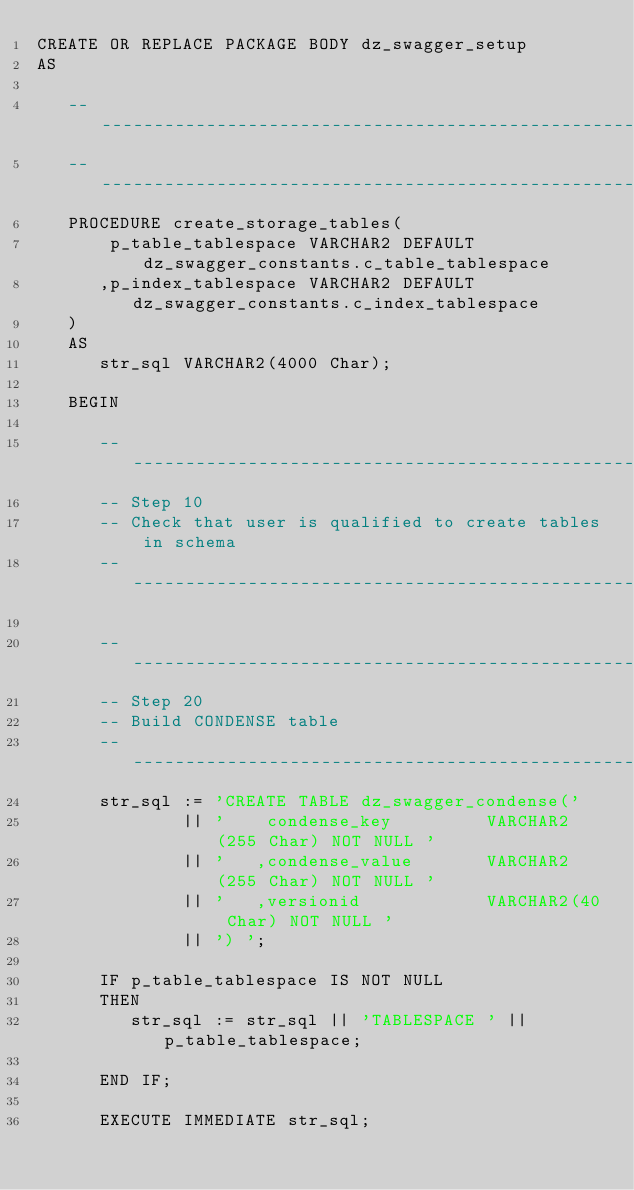<code> <loc_0><loc_0><loc_500><loc_500><_SQL_>CREATE OR REPLACE PACKAGE BODY dz_swagger_setup
AS

   -----------------------------------------------------------------------------
   -----------------------------------------------------------------------------
   PROCEDURE create_storage_tables(
       p_table_tablespace VARCHAR2 DEFAULT dz_swagger_constants.c_table_tablespace
      ,p_index_tablespace VARCHAR2 DEFAULT dz_swagger_constants.c_index_tablespace
   )
   AS
      str_sql VARCHAR2(4000 Char);
      
   BEGIN
   
      --------------------------------------------------------------------------
      -- Step 10
      -- Check that user is qualified to create tables in schema
      --------------------------------------------------------------------------
      
      --------------------------------------------------------------------------
      -- Step 20
      -- Build CONDENSE table
      --------------------------------------------------------------------------
      str_sql := 'CREATE TABLE dz_swagger_condense('
              || '    condense_key         VARCHAR2(255 Char) NOT NULL '
              || '   ,condense_value       VARCHAR2(255 Char) NOT NULL '
              || '   ,versionid            VARCHAR2(40 Char) NOT NULL '
              || ') ';
              
      IF p_table_tablespace IS NOT NULL
      THEN
         str_sql := str_sql || 'TABLESPACE ' || p_table_tablespace;
      
      END IF;
      
      EXECUTE IMMEDIATE str_sql;
      </code> 